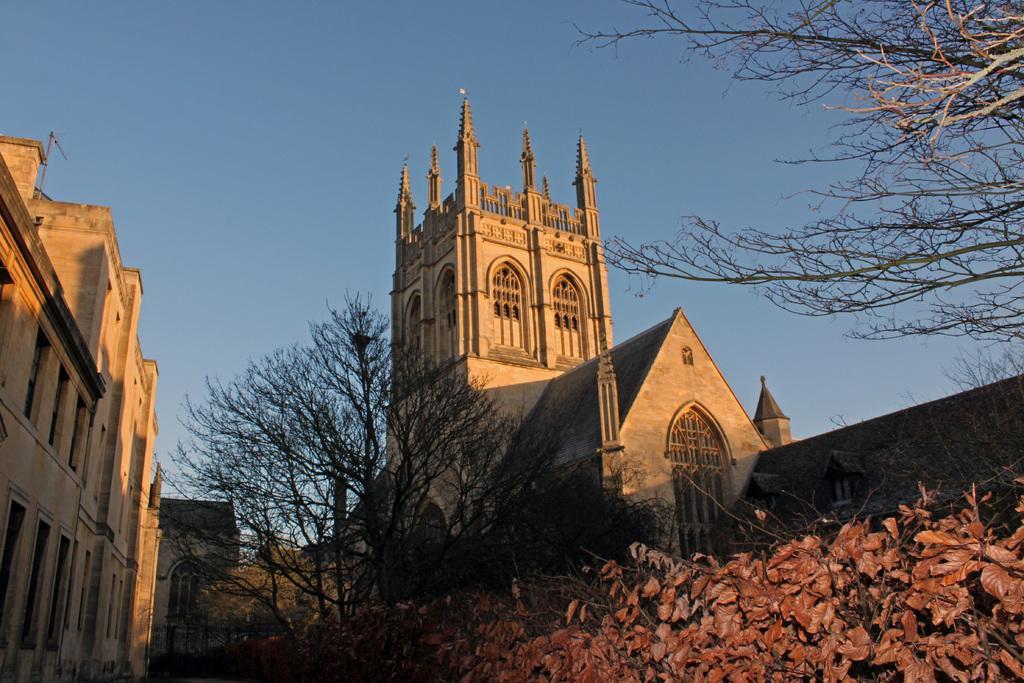Can you describe this image briefly? There are plants and trees in the foreground, it seems like a castle in the center and a building on the left side and the sky in the background area, there is a tree in the top right side. 